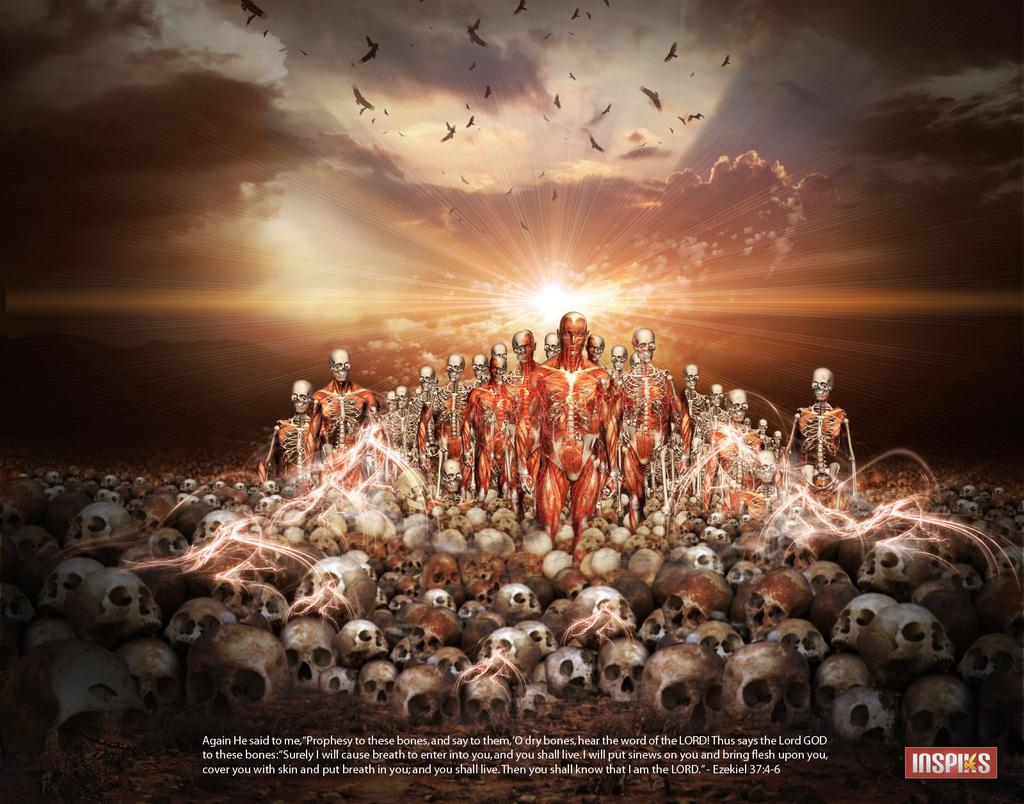Provide a one-sentence caption for the provided image. An Inspiks ad features skulls, bones, and walking skeletons. 